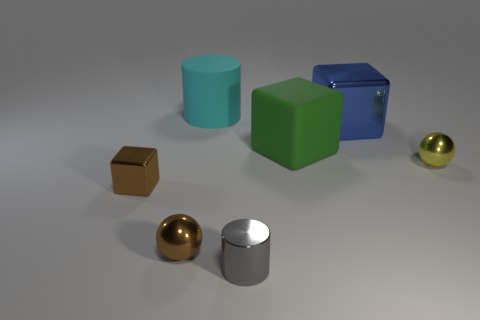What is the big blue cube made of?
Your answer should be compact. Metal. Are there more tiny red metal balls than big green things?
Ensure brevity in your answer.  No. Is the big cyan object the same shape as the blue metallic thing?
Keep it short and to the point. No. Is there any other thing that is the same shape as the gray shiny object?
Give a very brief answer. Yes. There is a rubber thing in front of the cyan rubber cylinder; is it the same color as the large thing that is right of the green matte thing?
Your response must be concise. No. Is the number of small yellow metallic spheres behind the yellow shiny thing less than the number of small yellow metal spheres to the left of the gray object?
Your answer should be compact. No. What is the shape of the shiny object behind the yellow thing?
Offer a terse response. Cube. There is a thing that is the same color as the small metal cube; what is its material?
Make the answer very short. Metal. What number of other objects are the same material as the gray cylinder?
Ensure brevity in your answer.  4. There is a blue object; does it have the same shape as the matte thing that is right of the matte cylinder?
Your response must be concise. Yes. 